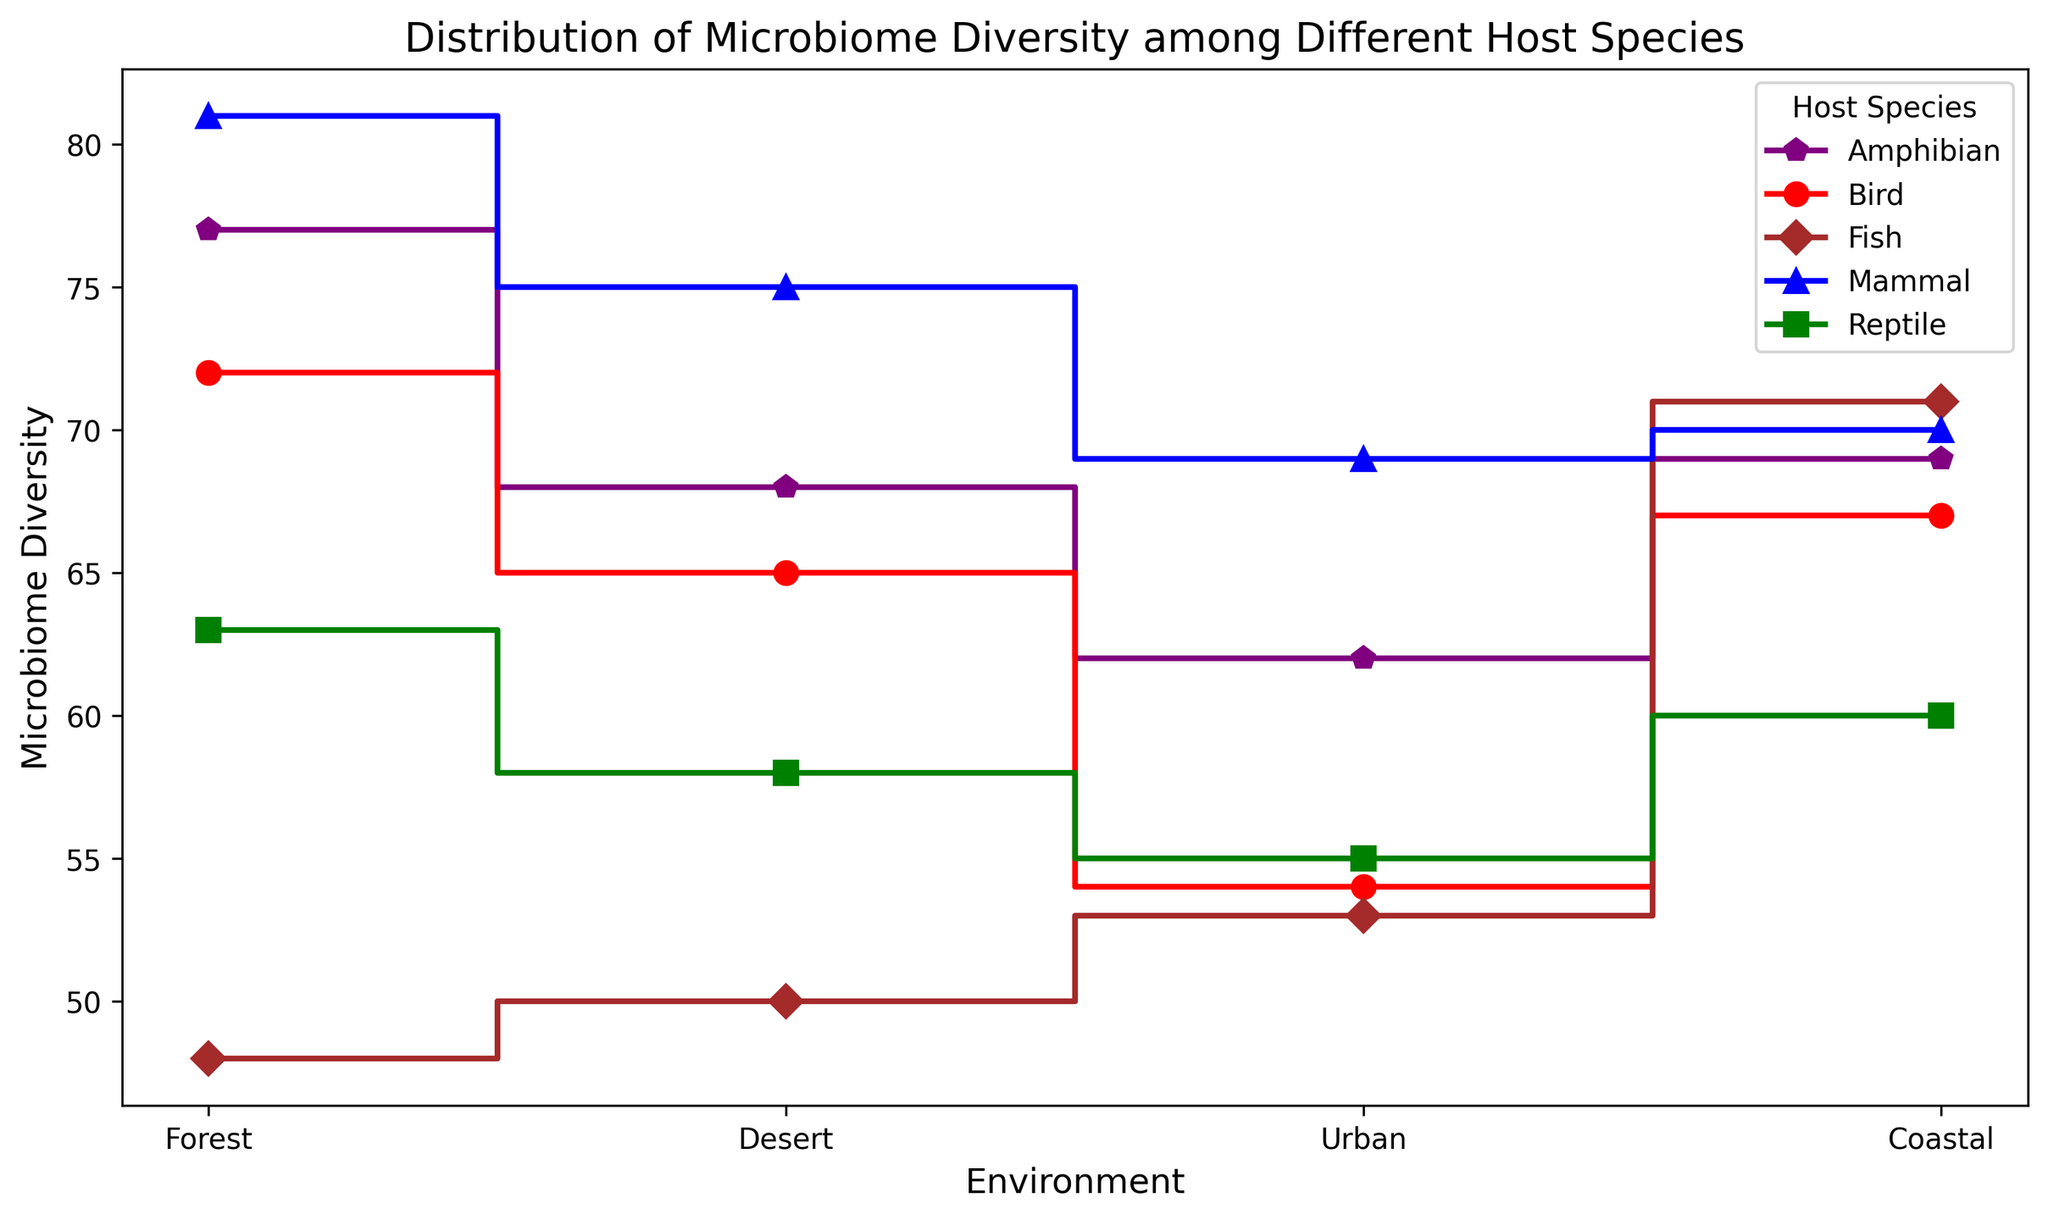What is the average microbiome diversity for Birds in all environments? To find the average diversity for Birds, sum the diversity values (72, 65, 54, 67) and divide by the number of environments (4). Thus, (72 + 65 + 54 + 67) / 4 = 64.5
Answer: 64.5 Which host species shows the highest microbiome diversity in the Coastal environment? To determine the highest diversity in the Coastal environment, compare the Coastal diversity values for all species: Bird (67), Mammal (70), Reptile (60), Amphibian (69), and Fish (71). Fish has the highest value at 71
Answer: Fish Is the microbiome diversity for Amphibians greater in the Forest or Coastal environment? Compare Amphibian's diversity in Forest (77) and Coastal (69). 77 > 69, so it is greater in the Forest
Answer: Forest Which species has the smallest range of microbiome diversity values across all environments? Calculate the range (max - min) for each species: 
- Bird: 72 - 54 = 18
- Mammal: 81 - 69 = 12
- Reptile: 63 - 55 = 8
- Amphibian: 77 - 62 = 15
- Fish: 71 - 48 = 23
Reptile has the smallest range at 8
Answer: Reptile Among environments, where does the Fish show the least microbiome diversity, and what is its value? Compare Fish's diversity values across environments: Forest (48), Desert (50), Urban (53), Coastal (71). The lowest is in the Forest with a value of 48
Answer: Forest, 48 For species that show increasing microbiome diversity from Forest to Coastal, which species have the highest final value? Identify species that increase from Forest to Coastal:
- Bird: 72 → 67 (decrease)
- Mammal: 81 → 70 (decrease)
- Reptile: 63 → 60 (decrease)
- Amphibian: 77 → 69 (decrease)
- Fish: 48 → 71 (increase)
Fish is the only species that meets the criteria, with the highest final value of 71
Answer: Fish, 71 